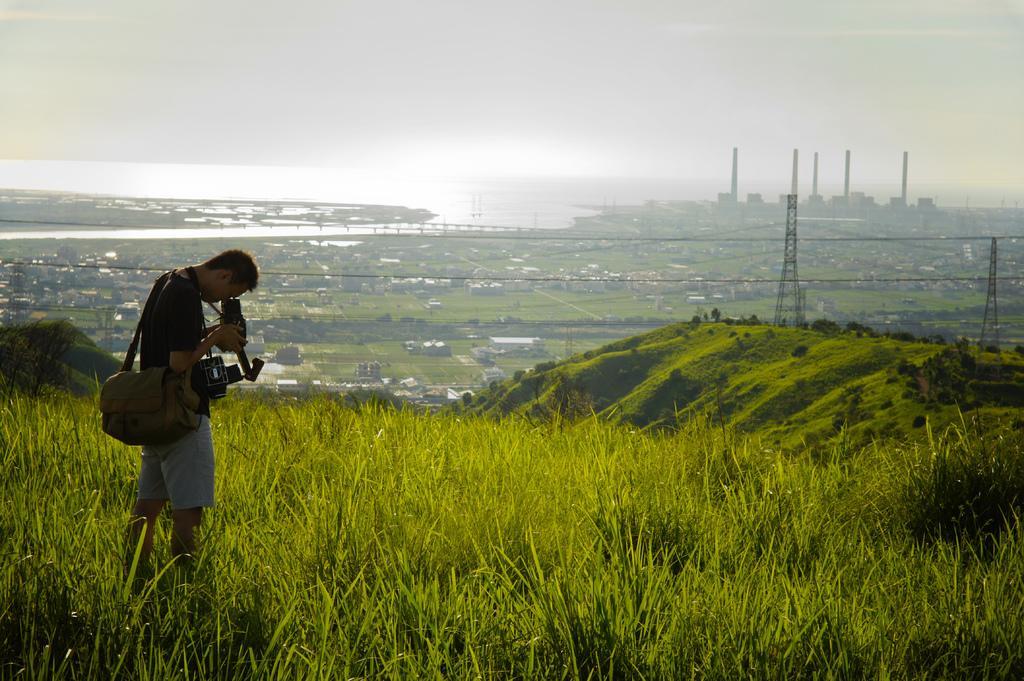Please provide a concise description of this image. In this picture we can see a man is standing on the grass surface and he is holding a camera and wearing a bag and far away from him we can see all crops, houses, poles and the sky. 